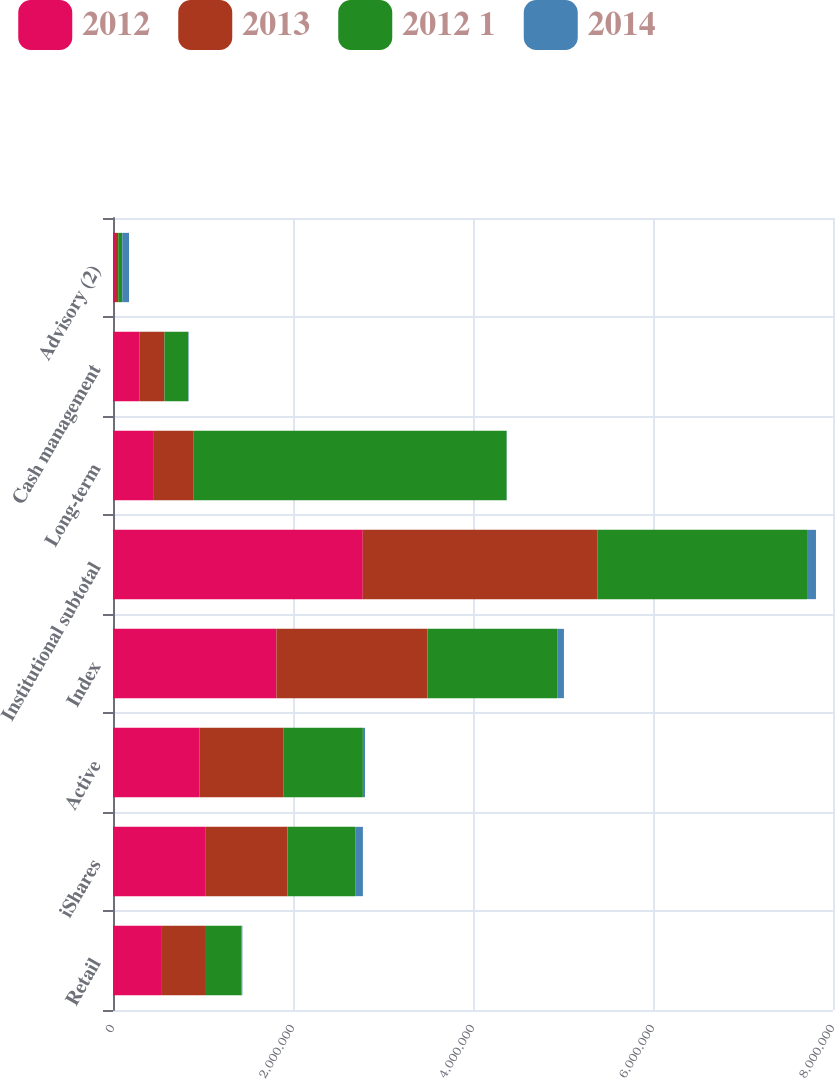Convert chart to OTSL. <chart><loc_0><loc_0><loc_500><loc_500><stacked_bar_chart><ecel><fcel>Retail<fcel>iShares<fcel>Active<fcel>Index<fcel>Institutional subtotal<fcel>Long-term<fcel>Cash management<fcel>Advisory (2)<nl><fcel>2012<fcel>534329<fcel>1.02423e+06<fcel>959160<fcel>1.81612e+06<fcel>2.77528e+06<fcel>445630<fcel>296353<fcel>21701<nl><fcel>2013<fcel>487777<fcel>914372<fcel>932410<fcel>1.67765e+06<fcel>2.61006e+06<fcel>445630<fcel>275554<fcel>36325<nl><fcel>2012 1<fcel>403484<fcel>752706<fcel>884695<fcel>1.44148e+06<fcel>2.32618e+06<fcel>3.48237e+06<fcel>263743<fcel>45479<nl><fcel>2014<fcel>11556<fcel>85167<fcel>24046<fcel>75142<fcel>99188<fcel>2465<fcel>5048<fcel>74540<nl></chart> 